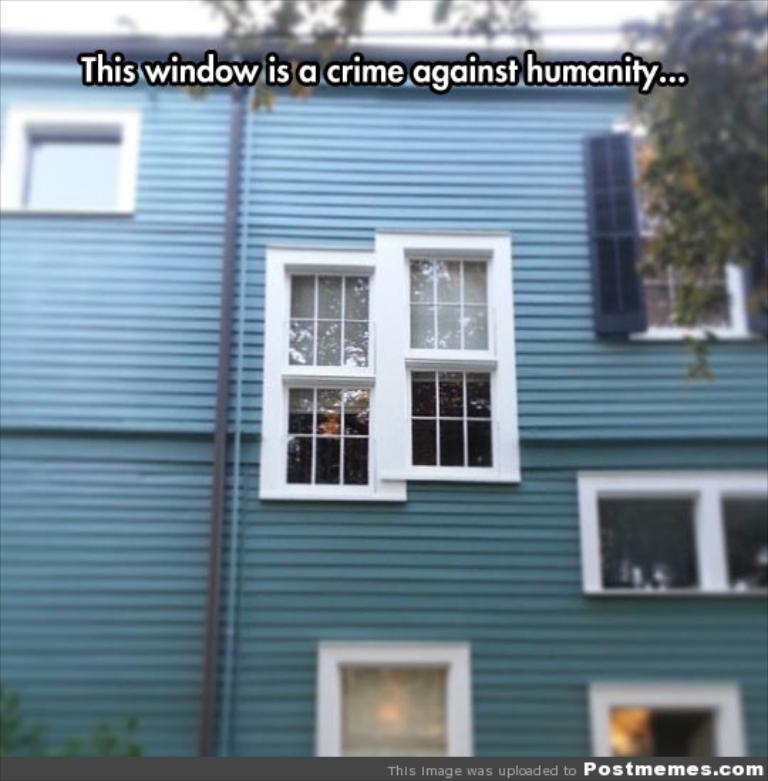Describe this image in one or two sentences. In this image we can see the front view of a building with the windows. At the top we can see the text and at the bottom we can also see the text on the border. 